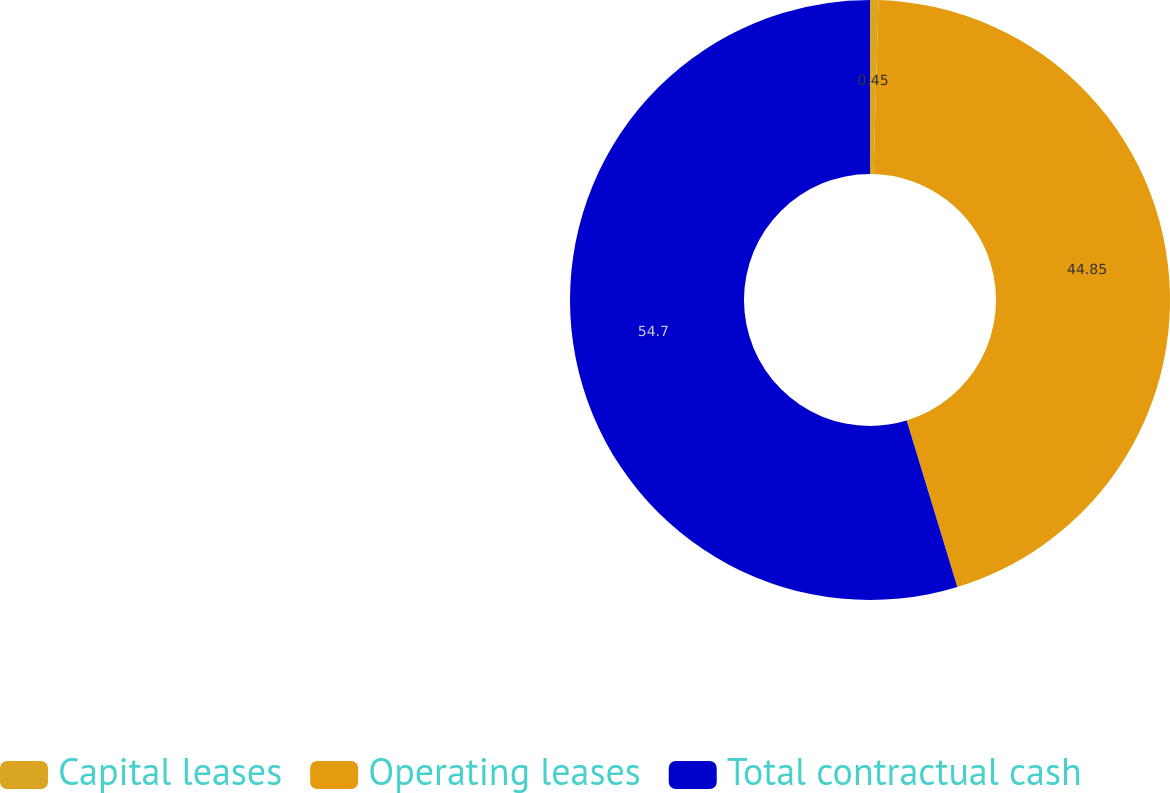<chart> <loc_0><loc_0><loc_500><loc_500><pie_chart><fcel>Capital leases<fcel>Operating leases<fcel>Total contractual cash<nl><fcel>0.45%<fcel>44.85%<fcel>54.7%<nl></chart> 